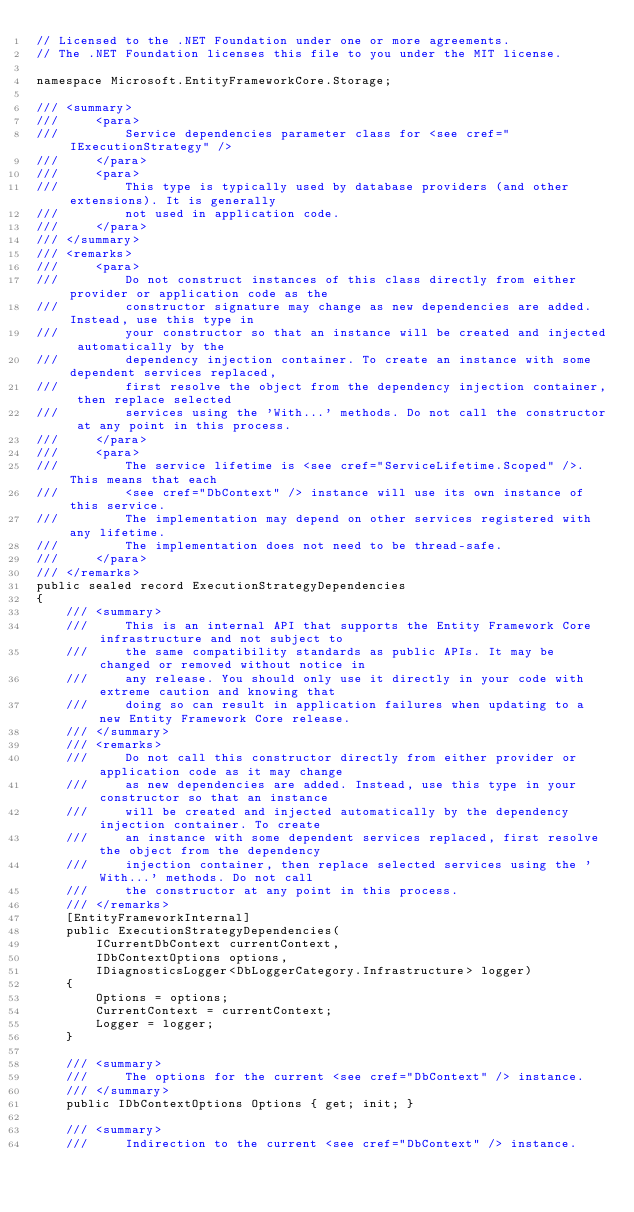<code> <loc_0><loc_0><loc_500><loc_500><_C#_>// Licensed to the .NET Foundation under one or more agreements.
// The .NET Foundation licenses this file to you under the MIT license.

namespace Microsoft.EntityFrameworkCore.Storage;

/// <summary>
///     <para>
///         Service dependencies parameter class for <see cref="IExecutionStrategy" />
///     </para>
///     <para>
///         This type is typically used by database providers (and other extensions). It is generally
///         not used in application code.
///     </para>
/// </summary>
/// <remarks>
///     <para>
///         Do not construct instances of this class directly from either provider or application code as the
///         constructor signature may change as new dependencies are added. Instead, use this type in
///         your constructor so that an instance will be created and injected automatically by the
///         dependency injection container. To create an instance with some dependent services replaced,
///         first resolve the object from the dependency injection container, then replace selected
///         services using the 'With...' methods. Do not call the constructor at any point in this process.
///     </para>
///     <para>
///         The service lifetime is <see cref="ServiceLifetime.Scoped" />. This means that each
///         <see cref="DbContext" /> instance will use its own instance of this service.
///         The implementation may depend on other services registered with any lifetime.
///         The implementation does not need to be thread-safe.
///     </para>
/// </remarks>
public sealed record ExecutionStrategyDependencies
{
    /// <summary>
    ///     This is an internal API that supports the Entity Framework Core infrastructure and not subject to
    ///     the same compatibility standards as public APIs. It may be changed or removed without notice in
    ///     any release. You should only use it directly in your code with extreme caution and knowing that
    ///     doing so can result in application failures when updating to a new Entity Framework Core release.
    /// </summary>
    /// <remarks>
    ///     Do not call this constructor directly from either provider or application code as it may change
    ///     as new dependencies are added. Instead, use this type in your constructor so that an instance
    ///     will be created and injected automatically by the dependency injection container. To create
    ///     an instance with some dependent services replaced, first resolve the object from the dependency
    ///     injection container, then replace selected services using the 'With...' methods. Do not call
    ///     the constructor at any point in this process.
    /// </remarks>
    [EntityFrameworkInternal]
    public ExecutionStrategyDependencies(
        ICurrentDbContext currentContext,
        IDbContextOptions options,
        IDiagnosticsLogger<DbLoggerCategory.Infrastructure> logger)
    {
        Options = options;
        CurrentContext = currentContext;
        Logger = logger;
    }

    /// <summary>
    ///     The options for the current <see cref="DbContext" /> instance.
    /// </summary>
    public IDbContextOptions Options { get; init; }

    /// <summary>
    ///     Indirection to the current <see cref="DbContext" /> instance.</code> 